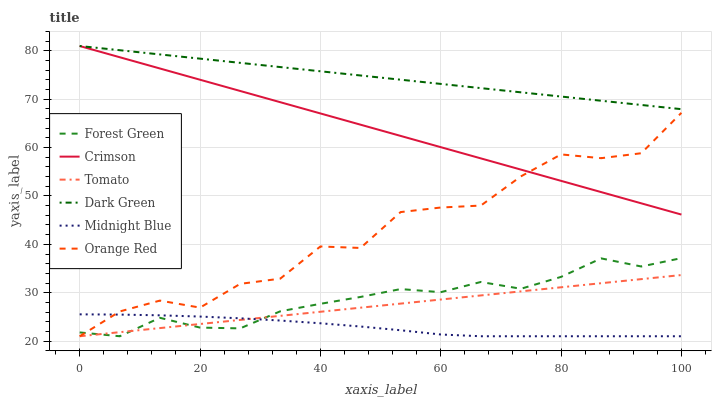Does Forest Green have the minimum area under the curve?
Answer yes or no. No. Does Forest Green have the maximum area under the curve?
Answer yes or no. No. Is Midnight Blue the smoothest?
Answer yes or no. No. Is Midnight Blue the roughest?
Answer yes or no. No. Does Crimson have the lowest value?
Answer yes or no. No. Does Forest Green have the highest value?
Answer yes or no. No. Is Tomato less than Dark Green?
Answer yes or no. Yes. Is Dark Green greater than Forest Green?
Answer yes or no. Yes. Does Tomato intersect Dark Green?
Answer yes or no. No. 